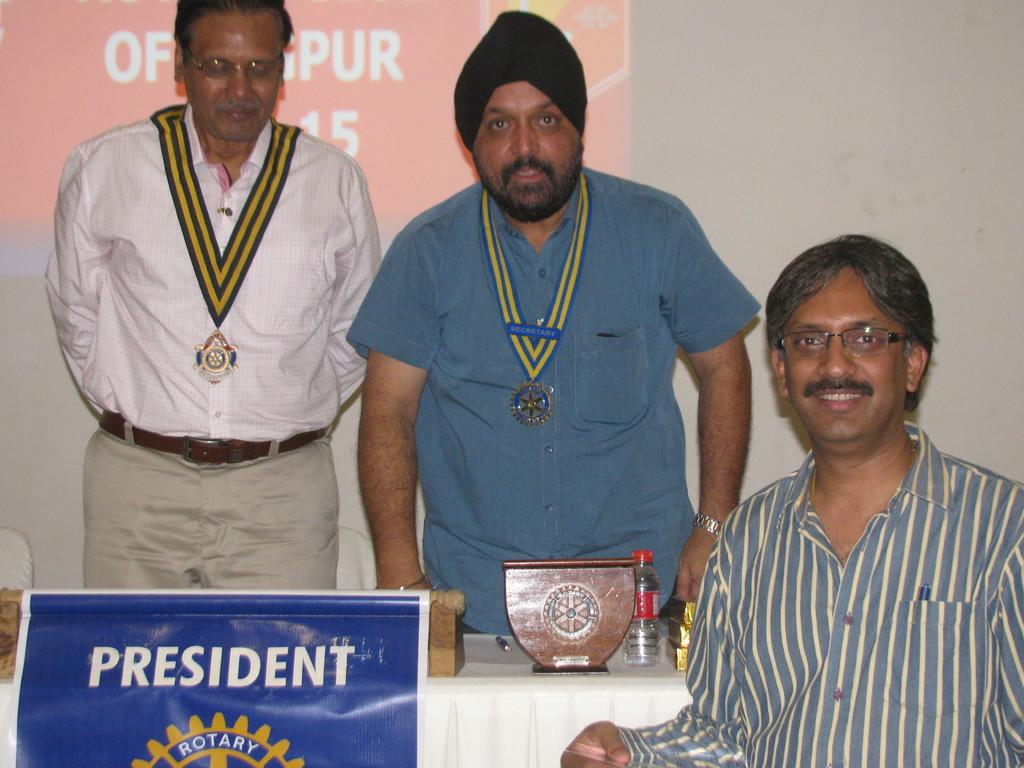<image>
Present a compact description of the photo's key features. a President sign in front of three guys 